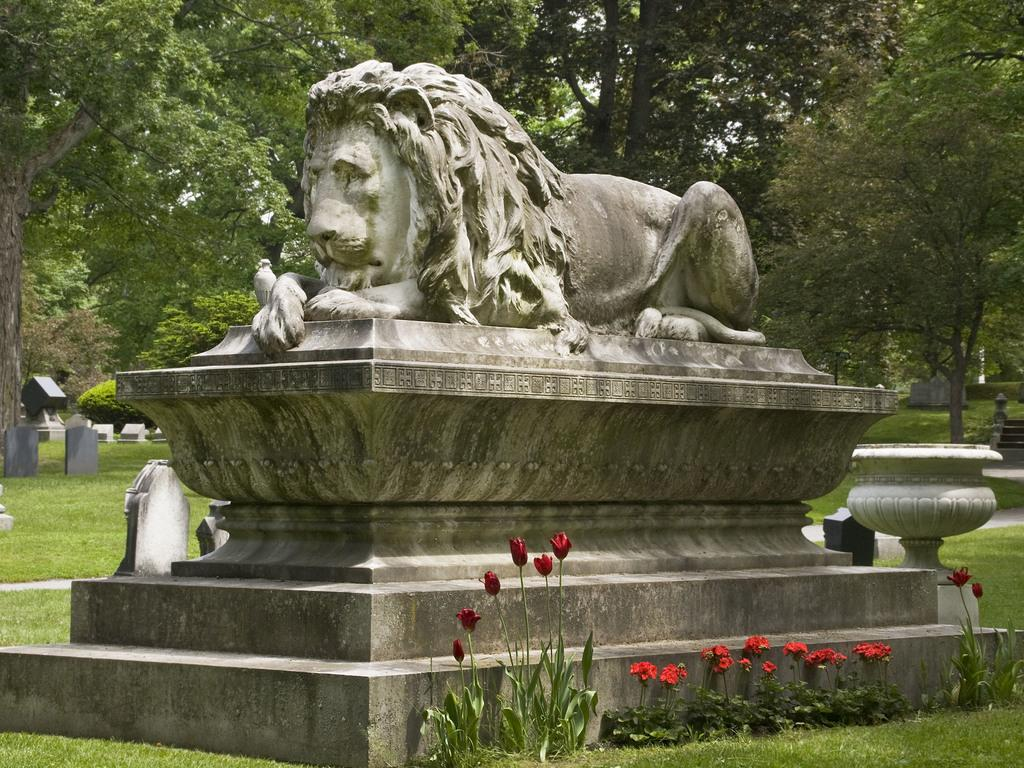What is the main subject of the image? There is a statue of a lion in the image. What can be seen in the background of the image? There are gravestones and trees in the background of the image. What type of vegetation is visible in the image? There is grass visible in the image. What else can be seen on the ground in the background of the image? There are other objects on the ground in the background of the image. Are there any plants visible in the image? Yes, there are flower plants in the image. What type of structure is being tested in the image? There is no structure being tested in the image; it features a statue of a lion and other elements in the background. Can you describe the roll of the lion in the image? The lion is a statue and does not have any actions or roles in the image. 